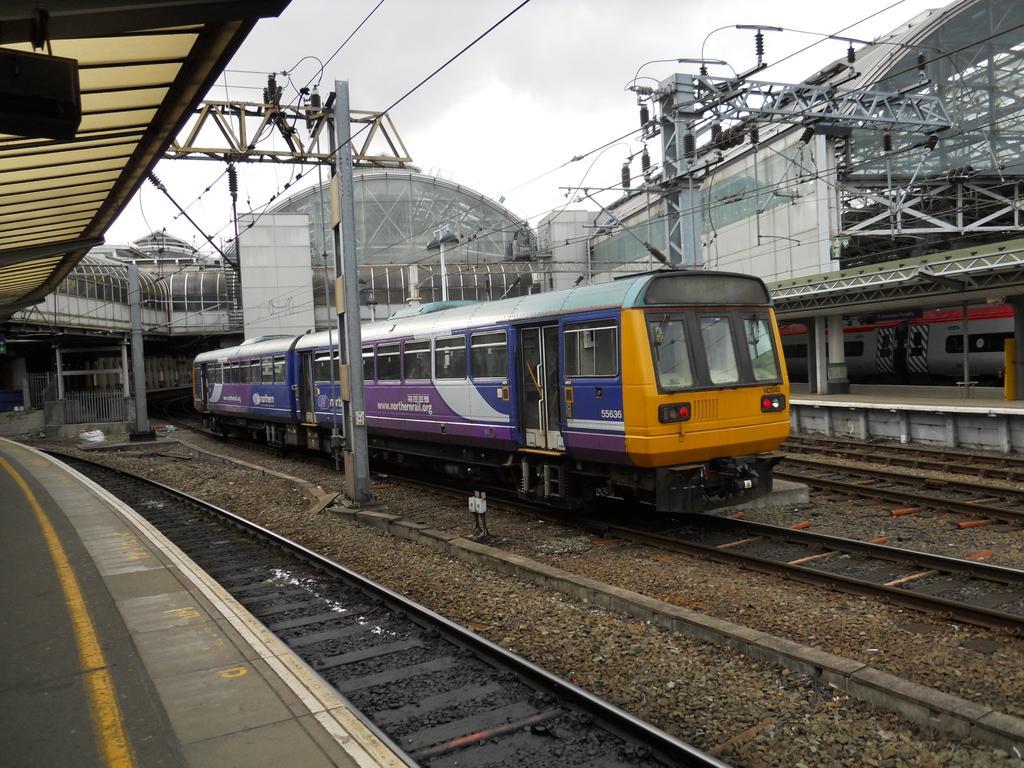Can you describe this image briefly? In this image I can see the train on the track. On both sides of the train I can see the platforms and the poles. In the background I can see the board, building and the sky. 